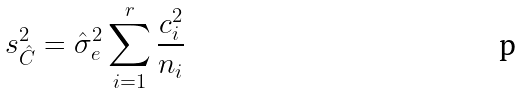<formula> <loc_0><loc_0><loc_500><loc_500>s _ { \hat { C } } ^ { 2 } = \hat { \sigma } _ { e } ^ { 2 } \sum _ { i = 1 } ^ { r } \frac { c _ { i } ^ { 2 } } { n _ { i } }</formula> 